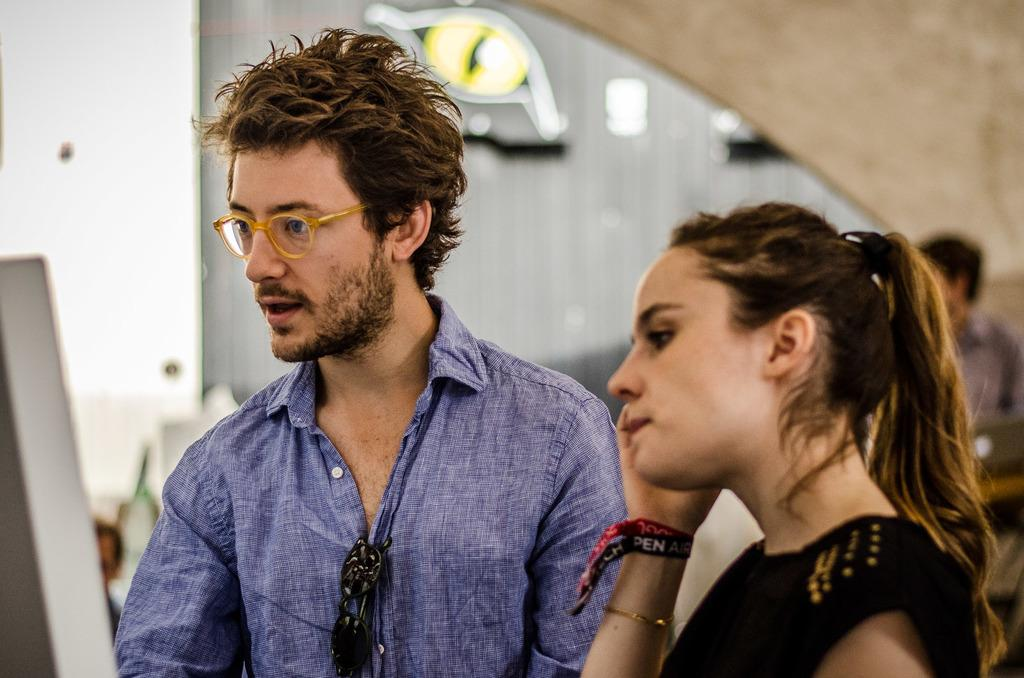Who are the people in the image? There is a man and a woman in the image. What are the positions of the man and woman in the image? Both the man and woman are standing. What can be seen in the background of the image? There are walls in the background of the image. What shape are the rabbits in the image? There are no rabbits present in the image. What type of mint is being used as a garnish in the image? There is no mint or any food items present in the image. 